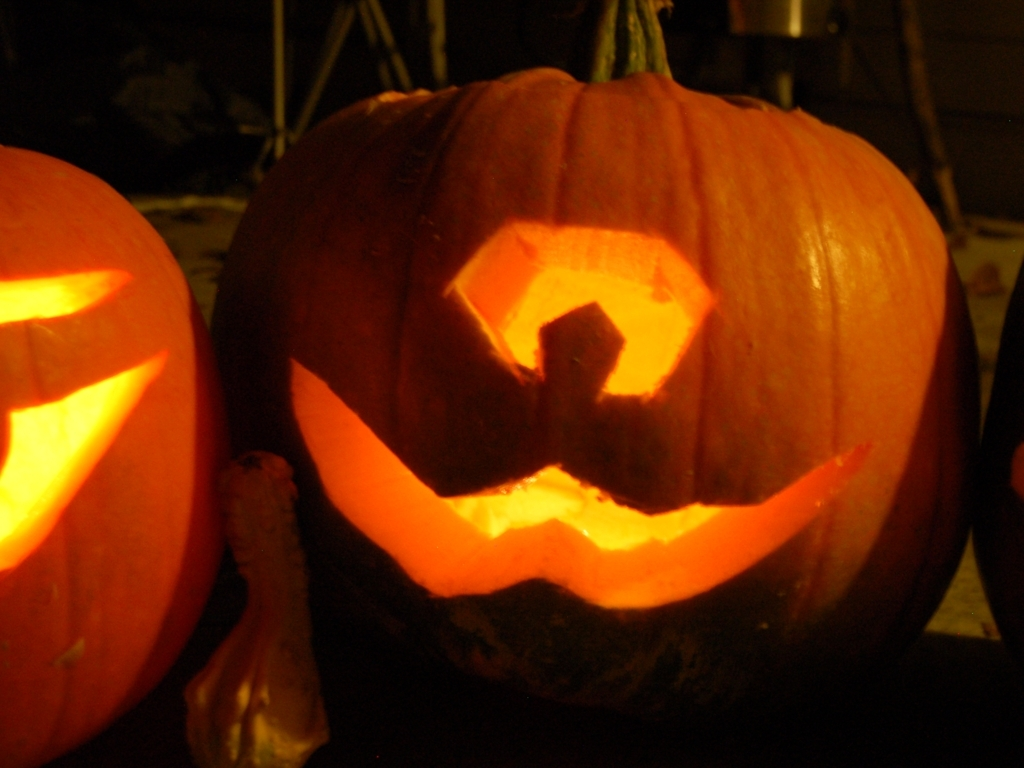What occasion might this pumpkin be carved for? This pumpkin, carved with a face, is commonly associated with Halloween celebrations, where such decorations are used to create a spooky atmosphere. 